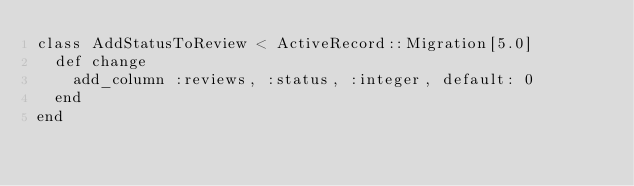Convert code to text. <code><loc_0><loc_0><loc_500><loc_500><_Ruby_>class AddStatusToReview < ActiveRecord::Migration[5.0]
  def change
    add_column :reviews, :status, :integer, default: 0
  end
end
</code> 